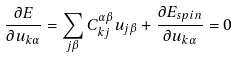<formula> <loc_0><loc_0><loc_500><loc_500>\frac { \partial E } { \partial { u _ { k \alpha } } } = \sum _ { j \beta } C _ { k j } ^ { \alpha \beta } u _ { j \beta } + \frac { \partial E _ { s p i n } } { \partial { u _ { k \alpha } } } = 0</formula> 